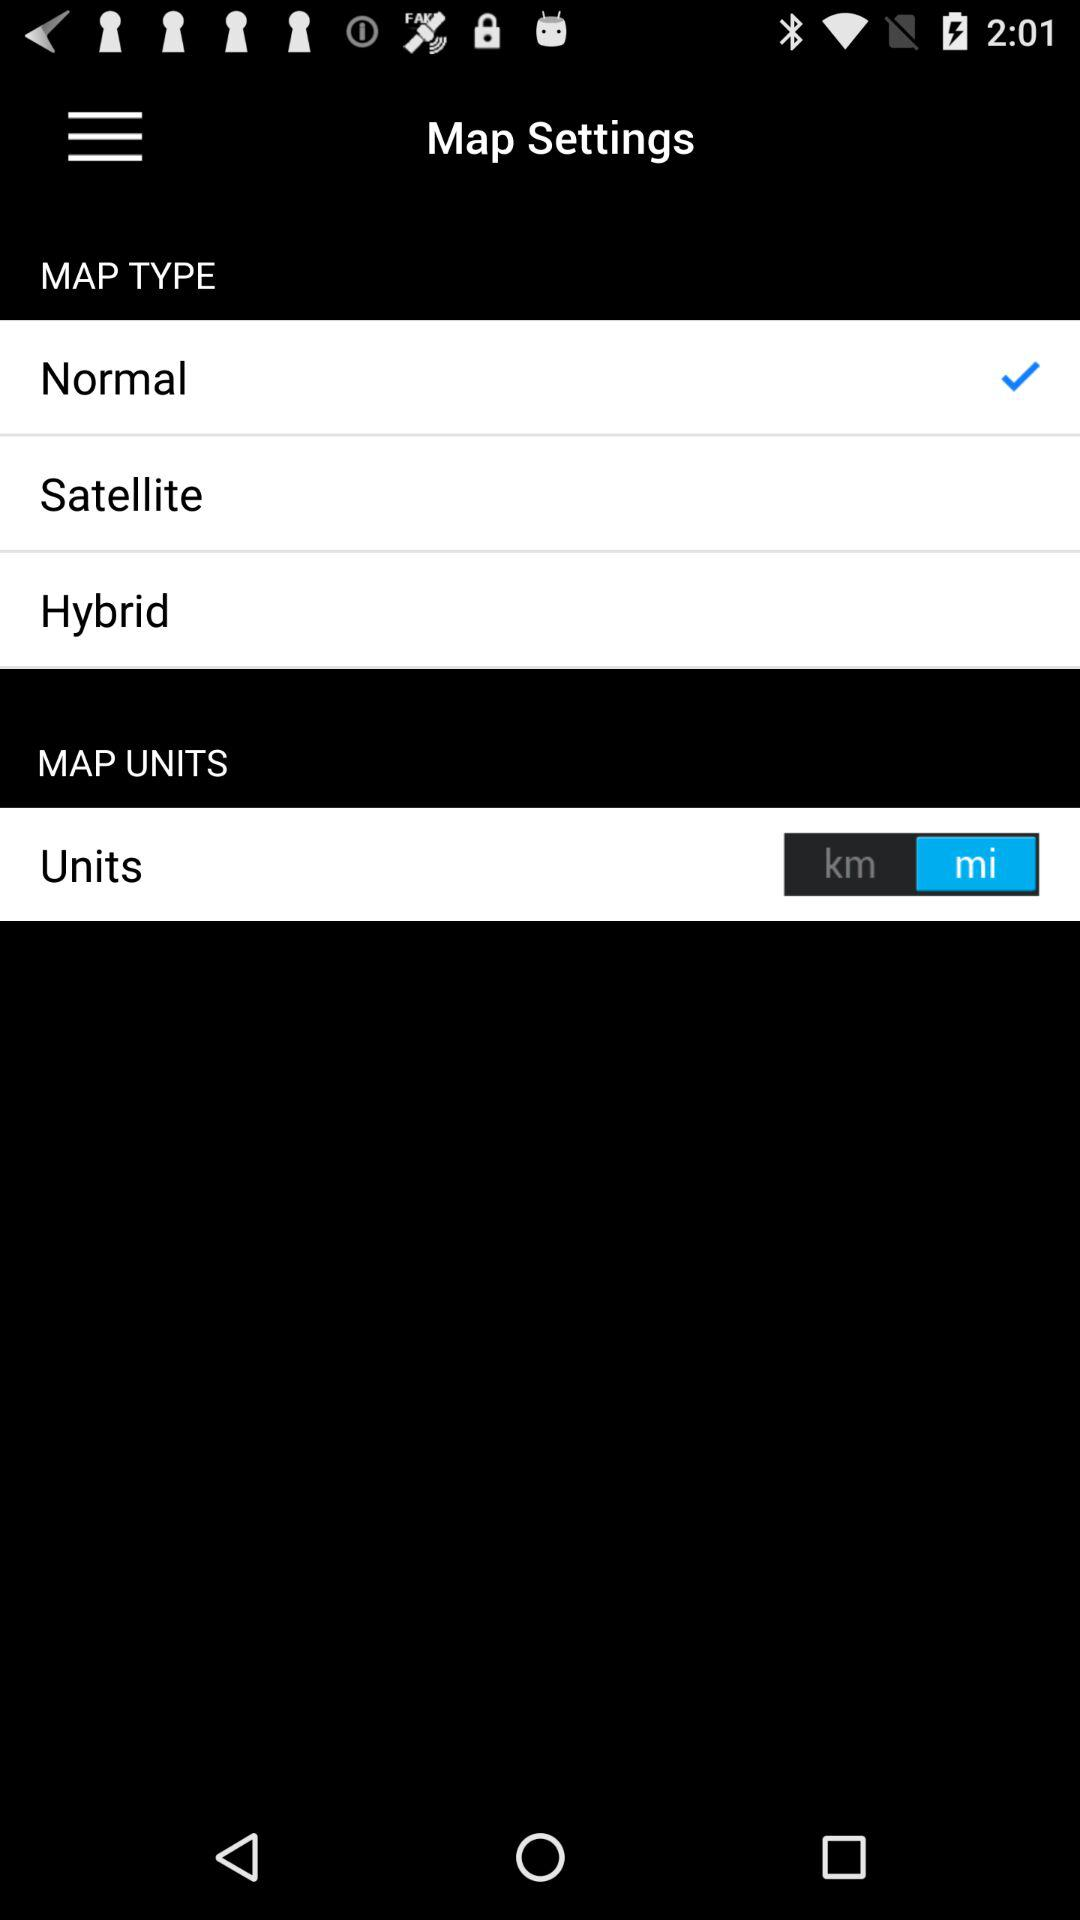How many map types are there?
Answer the question using a single word or phrase. 3 